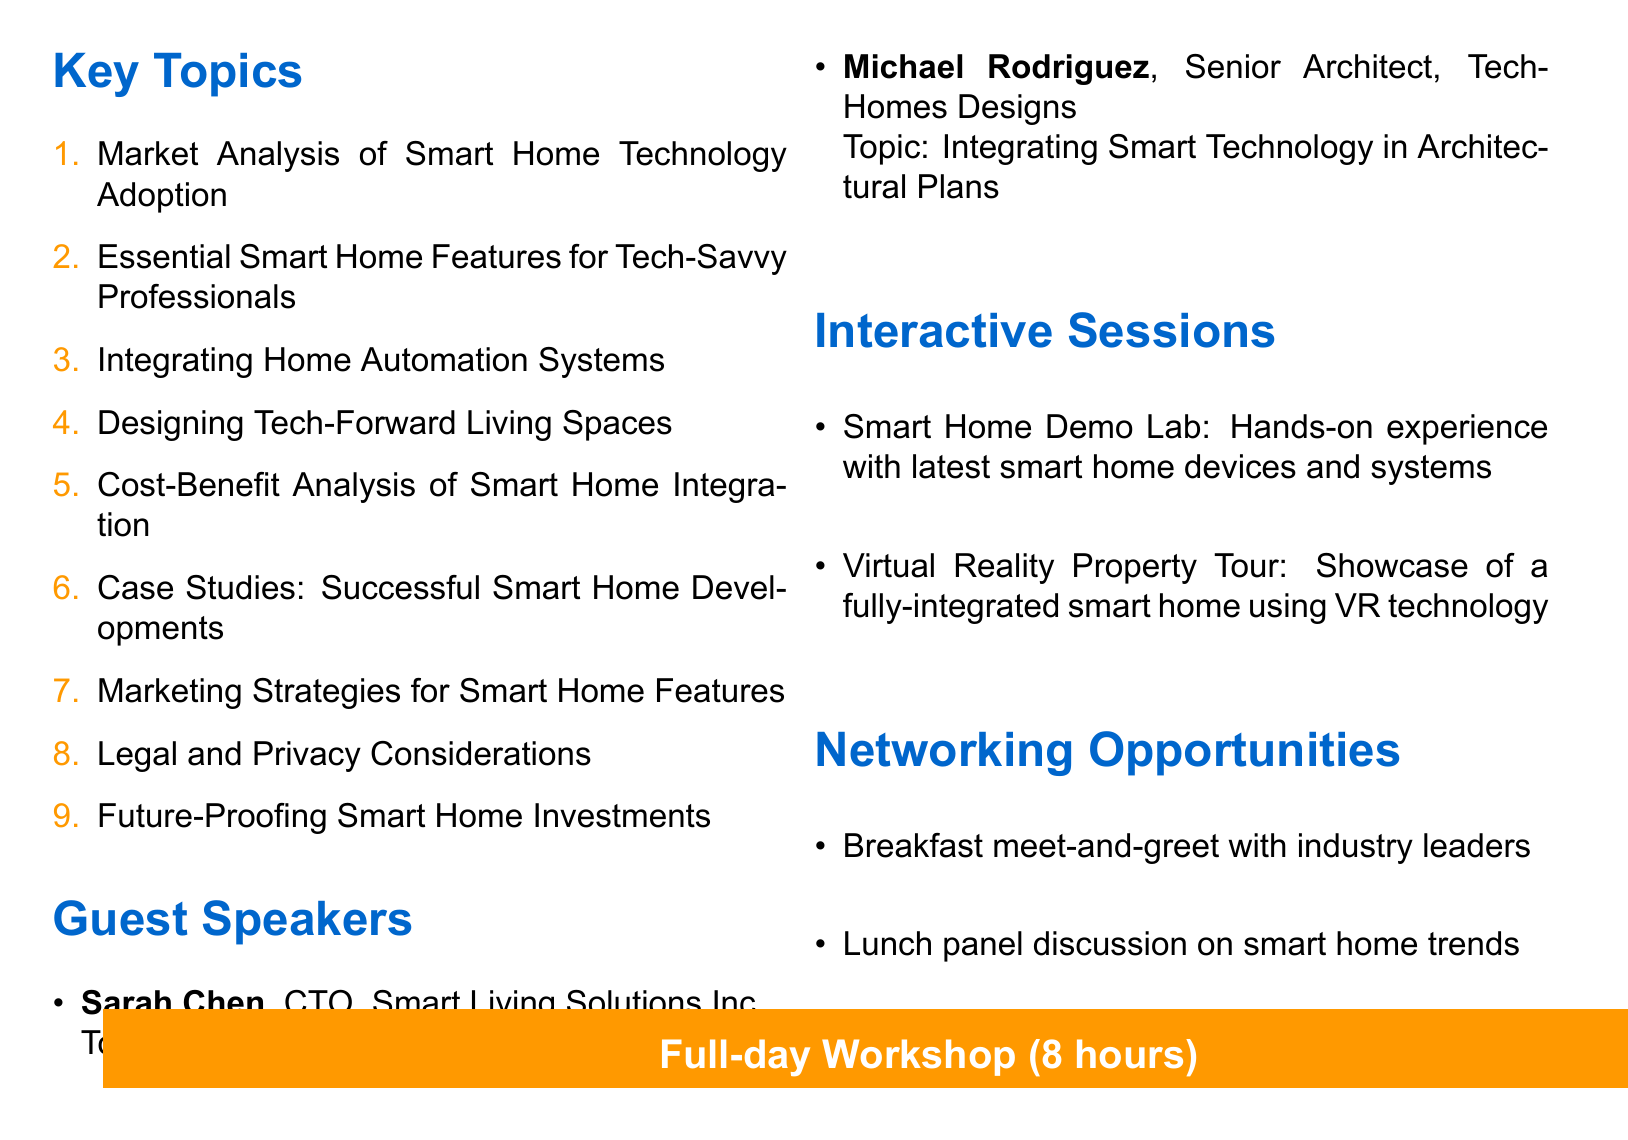What is the title of the workshop? The title of the workshop is clearly stated at the beginning of the document.
Answer: Integrating Smart Home Technologies for Tech-Savvy Professionals How long is the workshop? The duration of the workshop is mentioned in the footer section of the agenda.
Answer: Full-day (8 hours) Who is the first guest speaker? The document lists the guest speakers in a specific section and provides their titles.
Answer: Sarah Chen What is one essential feature for tech-savvy professionals? The key topics include specific essential features under their respective sections.
Answer: Smart security systems What is one interactive session listed in the agenda? The interactive sessions are outlined in a dedicated section with descriptions.
Answer: Smart Home Demo Lab Which city is mentioned in the case studies? The case studies section includes specific locations of successful smart home developments.
Answer: New York City What type of professionals is the target audience? The document clearly identifies the target demographic for the workshop.
Answer: Young professionals in tech industries What is one marketing strategy mentioned for smart home features? The document includes marketing strategies tailored for the target audience.
Answer: Highlighting tech amenities in property listings What legal consideration is noted in the workshop? Legal and privacy considerations are explicitly listed in the document.
Answer: Data protection and cybersecurity measures 